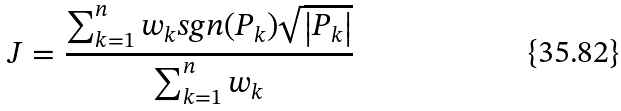Convert formula to latex. <formula><loc_0><loc_0><loc_500><loc_500>J = \frac { \sum _ { k = 1 } ^ { n } w _ { k } s g n ( P _ { k } ) \sqrt { \left | P _ { k } \right | } } { \sum _ { k = 1 } ^ { n } w _ { k } }</formula> 